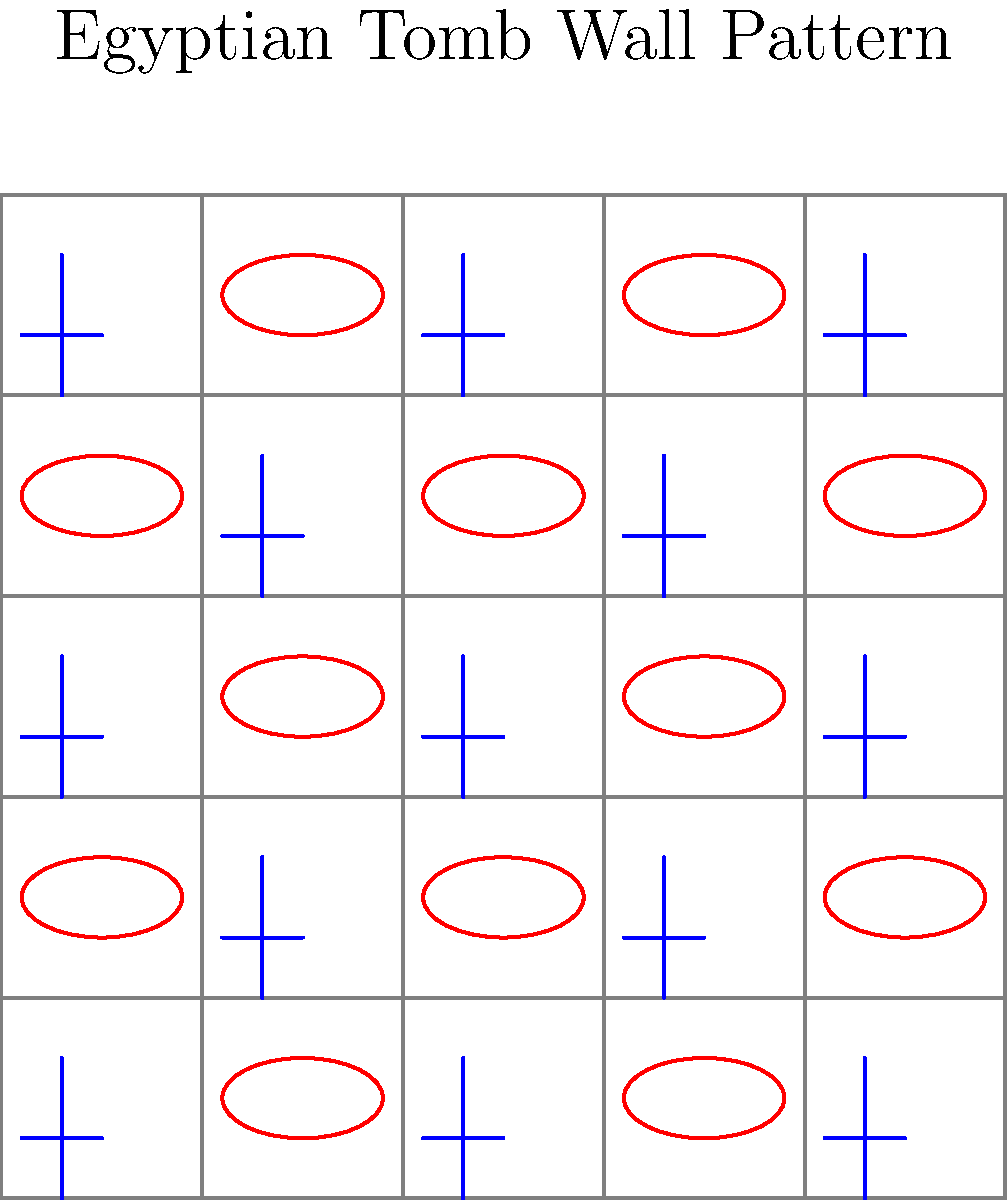In the context of computer vision analysis of Egyptian tomb wall paintings, what type of pattern recognition algorithm would be most effective in identifying the alternating sequence of symbols shown in the image, and how might this approach contribute to feminist interpretations of ancient Egyptian iconography? To answer this question, let's break it down into steps:

1. Pattern recognition: The image shows a 5x5 grid with alternating symbols - an ankh (☥) and an Eye of Horus (𓂀). This creates a checkerboard-like pattern.

2. Suitable algorithm: For this type of structured, repetitive pattern, a Convolutional Neural Network (CNN) would be most effective. CNNs are particularly good at identifying spatial hierarchies and patterns in images.

3. CNN application:
   a) The CNN would learn to recognize the individual symbols (ankh and Eye of Horus).
   b) It would then identify the alternating pattern across the grid.
   c) The network could be trained on various tomb wall paintings to generalize this pattern recognition.

4. Feminist interpretation contribution:
   a) The ankh symbolizes life, while the Eye of Horus represents protection and royal power.
   b) The equal representation and alternation of these symbols could suggest a balance between life-giving (often associated with feminine) and protective (often associated with masculine) forces in Egyptian theology.
   c) This automated pattern recognition could help identify similar balanced representations in other tomb paintings, potentially revealing new insights into gender roles and power dynamics in ancient Egyptian society.

5. Benefits of this approach:
   a) Objectivity: The algorithm provides an unbiased analysis of symbol frequency and arrangement.
   b) Efficiency: It can process large datasets of tomb paintings quickly.
   c) Pattern discovery: It might reveal subtle patterns that human observers have overlooked.

6. Feminist Egyptology application:
   a) Challenging traditional interpretations: Automated pattern recognition could provide evidence to question male-centric interpretations of Egyptian iconography.
   b) Revealing female agency: Identifying patterns that emphasize feminine symbols could highlight the importance of women in ancient Egyptian religion and politics.
   c) Intersectional analysis: The algorithm could be adapted to recognize symbols associated with different social classes, enabling a more nuanced understanding of gender roles across Egyptian society.
Answer: CNN for pattern recognition, revealing balanced gender representation in Egyptian iconography 